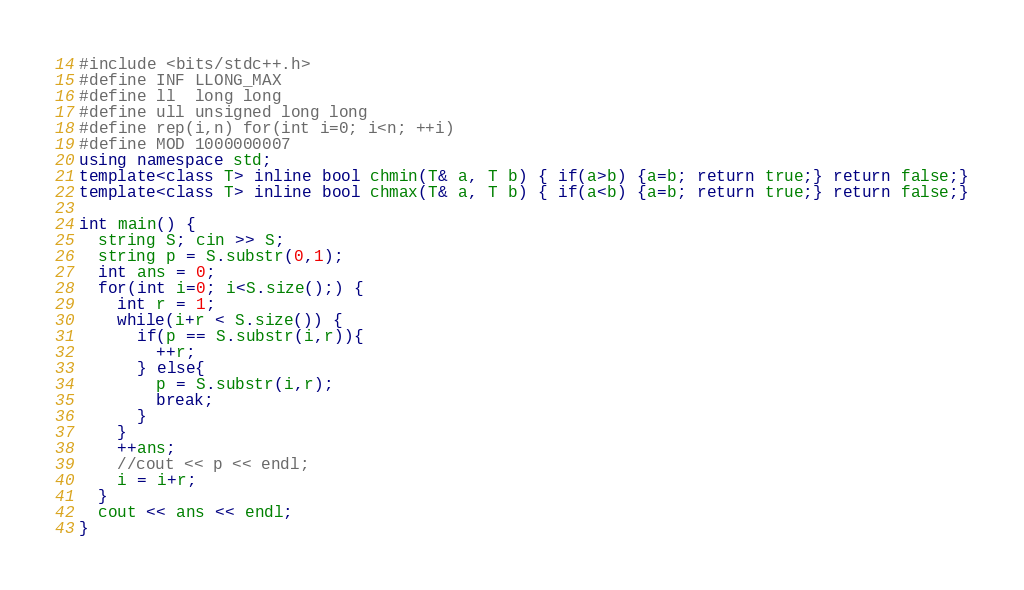<code> <loc_0><loc_0><loc_500><loc_500><_C++_>#include <bits/stdc++.h>
#define INF LLONG_MAX
#define ll  long long
#define ull unsigned long long
#define rep(i,n) for(int i=0; i<n; ++i)
#define MOD 1000000007
using namespace std;
template<class T> inline bool chmin(T& a, T b) { if(a>b) {a=b; return true;} return false;}
template<class T> inline bool chmax(T& a, T b) { if(a<b) {a=b; return true;} return false;}

int main() {
  string S; cin >> S;
  string p = S.substr(0,1);
  int ans = 0;
  for(int i=0; i<S.size();) {
    int r = 1;
    while(i+r < S.size()) {
      if(p == S.substr(i,r)){
        ++r;
      } else{
        p = S.substr(i,r);
        break;
      }
    }
    ++ans;
    //cout << p << endl;
    i = i+r;
  }
  cout << ans << endl;
}
</code> 